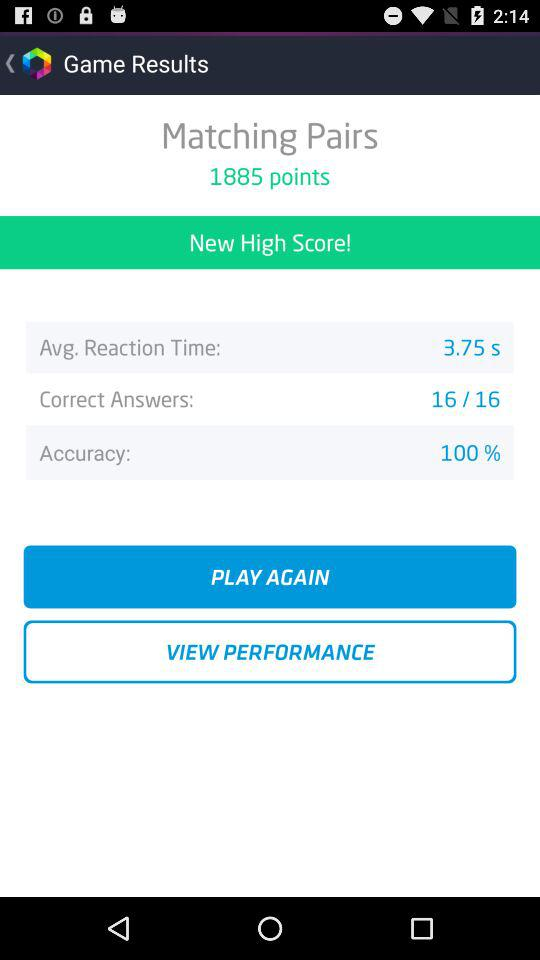How many correct answers are there? There are 16 correct answers. 